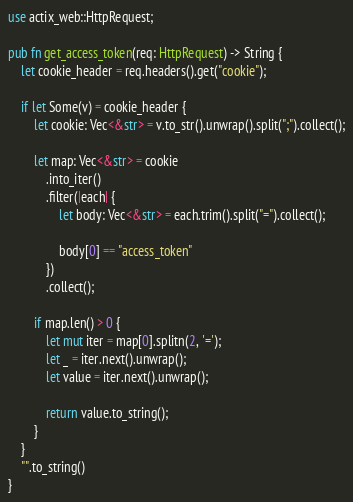Convert code to text. <code><loc_0><loc_0><loc_500><loc_500><_Rust_>use actix_web::HttpRequest;

pub fn get_access_token(req: HttpRequest) -> String {
    let cookie_header = req.headers().get("cookie");

    if let Some(v) = cookie_header {
        let cookie: Vec<&str> = v.to_str().unwrap().split(";").collect();

        let map: Vec<&str> = cookie
            .into_iter()
            .filter(|each| {
                let body: Vec<&str> = each.trim().split("=").collect();

                body[0] == "access_token"
            })
            .collect();

        if map.len() > 0 {
            let mut iter = map[0].splitn(2, '=');
            let _ = iter.next().unwrap();
            let value = iter.next().unwrap();

            return value.to_string();
        }
    }
    "".to_string()
}
</code> 